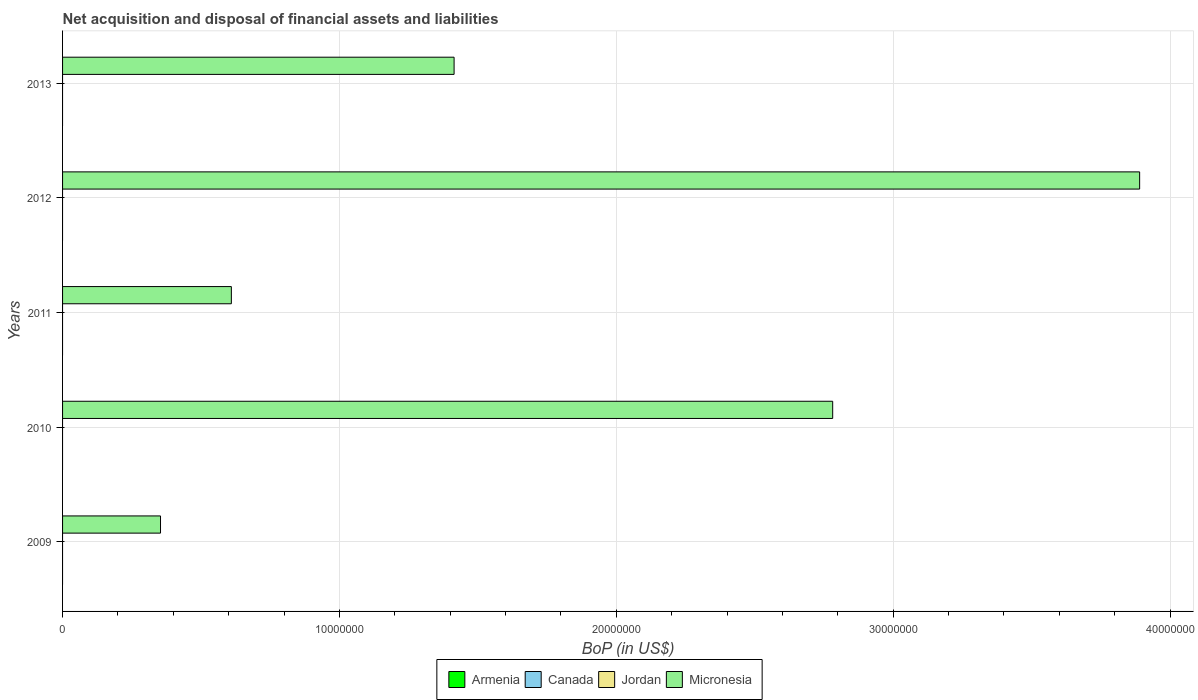Are the number of bars per tick equal to the number of legend labels?
Offer a very short reply. No. How many bars are there on the 4th tick from the top?
Provide a short and direct response. 1. What is the Balance of Payments in Micronesia in 2013?
Your answer should be compact. 1.41e+07. In which year was the Balance of Payments in Micronesia maximum?
Keep it short and to the point. 2012. What is the difference between the Balance of Payments in Micronesia in 2011 and that in 2013?
Your response must be concise. -8.04e+06. What is the difference between the Balance of Payments in Canada in 2011 and the Balance of Payments in Micronesia in 2012?
Your response must be concise. -3.89e+07. In how many years, is the Balance of Payments in Canada greater than 20000000 US$?
Provide a succinct answer. 0. What is the ratio of the Balance of Payments in Micronesia in 2010 to that in 2012?
Provide a short and direct response. 0.72. What is the difference between the highest and the second highest Balance of Payments in Micronesia?
Give a very brief answer. 1.11e+07. What is the difference between the highest and the lowest Balance of Payments in Micronesia?
Your answer should be compact. 3.54e+07. In how many years, is the Balance of Payments in Armenia greater than the average Balance of Payments in Armenia taken over all years?
Your answer should be very brief. 0. Is it the case that in every year, the sum of the Balance of Payments in Canada and Balance of Payments in Armenia is greater than the Balance of Payments in Micronesia?
Your response must be concise. No. How many bars are there?
Offer a very short reply. 5. Are all the bars in the graph horizontal?
Your answer should be compact. Yes. What is the difference between two consecutive major ticks on the X-axis?
Provide a succinct answer. 1.00e+07. Where does the legend appear in the graph?
Offer a terse response. Bottom center. How many legend labels are there?
Give a very brief answer. 4. How are the legend labels stacked?
Provide a short and direct response. Horizontal. What is the title of the graph?
Your answer should be compact. Net acquisition and disposal of financial assets and liabilities. What is the label or title of the X-axis?
Offer a terse response. BoP (in US$). What is the BoP (in US$) in Micronesia in 2009?
Keep it short and to the point. 3.54e+06. What is the BoP (in US$) of Canada in 2010?
Keep it short and to the point. 0. What is the BoP (in US$) of Jordan in 2010?
Your answer should be compact. 0. What is the BoP (in US$) of Micronesia in 2010?
Give a very brief answer. 2.78e+07. What is the BoP (in US$) in Canada in 2011?
Your answer should be compact. 0. What is the BoP (in US$) in Jordan in 2011?
Ensure brevity in your answer.  0. What is the BoP (in US$) of Micronesia in 2011?
Offer a terse response. 6.10e+06. What is the BoP (in US$) in Jordan in 2012?
Provide a short and direct response. 0. What is the BoP (in US$) of Micronesia in 2012?
Ensure brevity in your answer.  3.89e+07. What is the BoP (in US$) in Armenia in 2013?
Your response must be concise. 0. What is the BoP (in US$) in Canada in 2013?
Ensure brevity in your answer.  0. What is the BoP (in US$) in Jordan in 2013?
Provide a succinct answer. 0. What is the BoP (in US$) in Micronesia in 2013?
Your response must be concise. 1.41e+07. Across all years, what is the maximum BoP (in US$) of Micronesia?
Offer a very short reply. 3.89e+07. Across all years, what is the minimum BoP (in US$) of Micronesia?
Offer a very short reply. 3.54e+06. What is the total BoP (in US$) in Armenia in the graph?
Provide a short and direct response. 0. What is the total BoP (in US$) of Micronesia in the graph?
Provide a succinct answer. 9.05e+07. What is the difference between the BoP (in US$) in Micronesia in 2009 and that in 2010?
Your answer should be compact. -2.43e+07. What is the difference between the BoP (in US$) of Micronesia in 2009 and that in 2011?
Provide a short and direct response. -2.56e+06. What is the difference between the BoP (in US$) in Micronesia in 2009 and that in 2012?
Offer a very short reply. -3.54e+07. What is the difference between the BoP (in US$) of Micronesia in 2009 and that in 2013?
Offer a very short reply. -1.06e+07. What is the difference between the BoP (in US$) in Micronesia in 2010 and that in 2011?
Provide a short and direct response. 2.17e+07. What is the difference between the BoP (in US$) in Micronesia in 2010 and that in 2012?
Make the answer very short. -1.11e+07. What is the difference between the BoP (in US$) in Micronesia in 2010 and that in 2013?
Provide a succinct answer. 1.37e+07. What is the difference between the BoP (in US$) in Micronesia in 2011 and that in 2012?
Offer a very short reply. -3.28e+07. What is the difference between the BoP (in US$) in Micronesia in 2011 and that in 2013?
Make the answer very short. -8.04e+06. What is the difference between the BoP (in US$) in Micronesia in 2012 and that in 2013?
Your response must be concise. 2.48e+07. What is the average BoP (in US$) in Jordan per year?
Provide a short and direct response. 0. What is the average BoP (in US$) in Micronesia per year?
Provide a succinct answer. 1.81e+07. What is the ratio of the BoP (in US$) in Micronesia in 2009 to that in 2010?
Offer a terse response. 0.13. What is the ratio of the BoP (in US$) of Micronesia in 2009 to that in 2011?
Keep it short and to the point. 0.58. What is the ratio of the BoP (in US$) in Micronesia in 2009 to that in 2012?
Make the answer very short. 0.09. What is the ratio of the BoP (in US$) of Micronesia in 2009 to that in 2013?
Make the answer very short. 0.25. What is the ratio of the BoP (in US$) of Micronesia in 2010 to that in 2011?
Offer a very short reply. 4.56. What is the ratio of the BoP (in US$) of Micronesia in 2010 to that in 2012?
Make the answer very short. 0.71. What is the ratio of the BoP (in US$) of Micronesia in 2010 to that in 2013?
Make the answer very short. 1.97. What is the ratio of the BoP (in US$) of Micronesia in 2011 to that in 2012?
Give a very brief answer. 0.16. What is the ratio of the BoP (in US$) in Micronesia in 2011 to that in 2013?
Your answer should be compact. 0.43. What is the ratio of the BoP (in US$) of Micronesia in 2012 to that in 2013?
Offer a very short reply. 2.75. What is the difference between the highest and the second highest BoP (in US$) in Micronesia?
Keep it short and to the point. 1.11e+07. What is the difference between the highest and the lowest BoP (in US$) in Micronesia?
Offer a very short reply. 3.54e+07. 